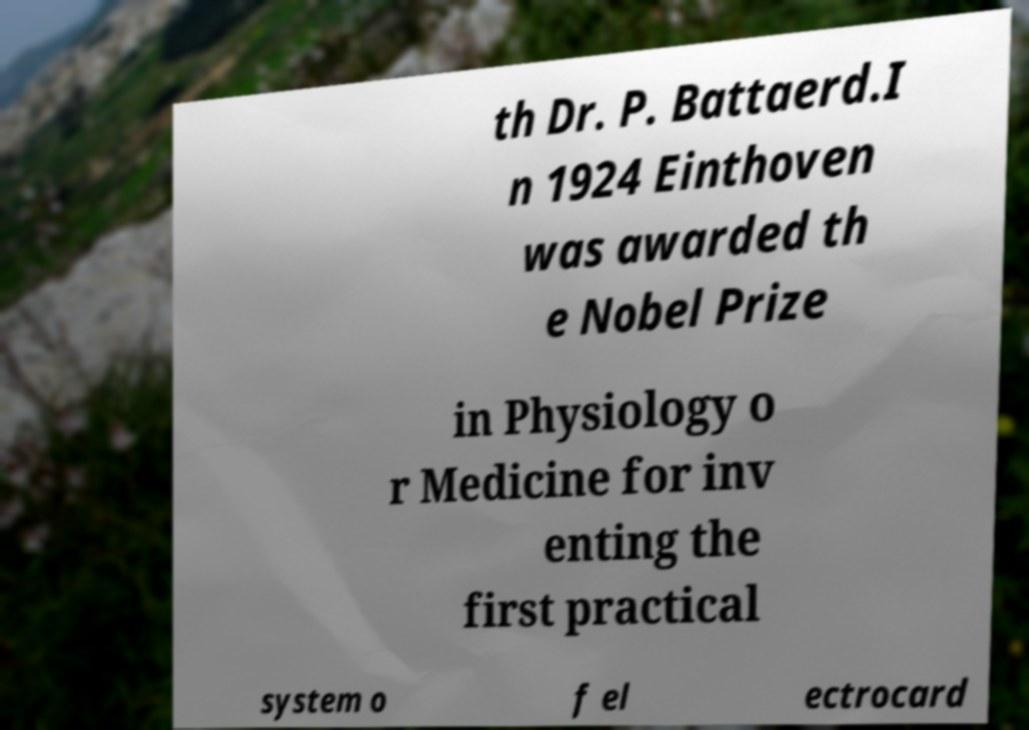There's text embedded in this image that I need extracted. Can you transcribe it verbatim? th Dr. P. Battaerd.I n 1924 Einthoven was awarded th e Nobel Prize in Physiology o r Medicine for inv enting the first practical system o f el ectrocard 